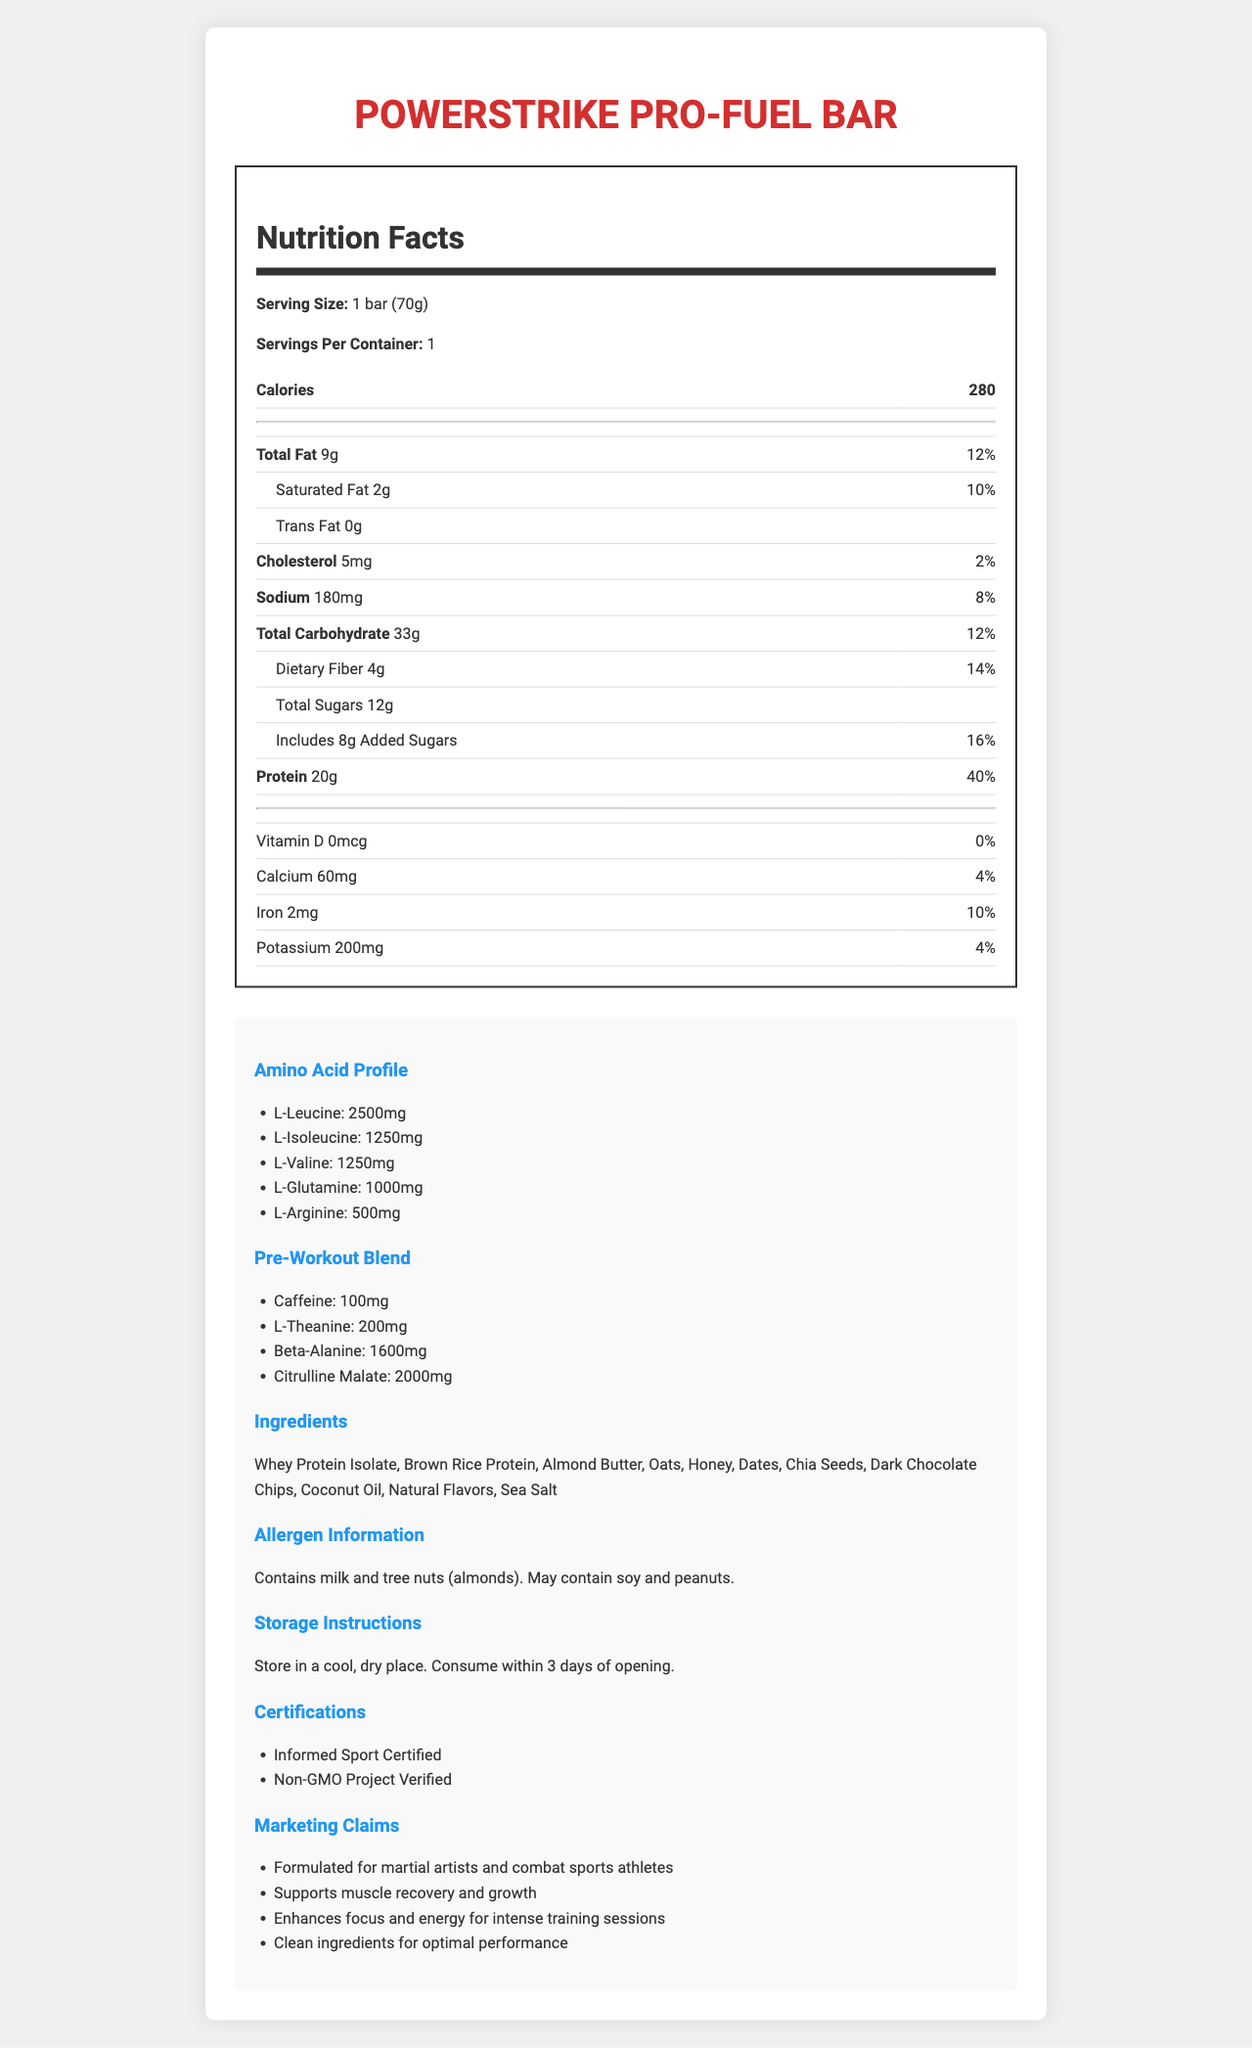What is the serving size of the PowerStrike Pro-Fuel Bar? The serving size is explicitly stated as "1 bar (70g)" in the Nutrition Facts section.
Answer: 1 bar (70g) How many calories are in one serving of the PowerStrike Pro-Fuel Bar? The document lists the calorie content as 280 in the Nutrition Facts section.
Answer: 280 calories List three main ingredients in the PowerStrike Pro-Fuel Bar. These ingredients are mentioned at the beginning of the ingredients list.
Answer: Whey Protein Isolate, Brown Rice Protein, Almond Butter What is the amount of protein in one bar of PowerStrike Pro-Fuel Bar? The document states that the protein content is 20g per serving in the Nutrition Facts section.
Answer: 20g What certifications does the PowerStrike Pro-Fuel Bar have? These certifications are listed under Certifications in the extra info section.
Answer: Informed Sport Certified, Non-GMO Project Verified What is the total fat content of the PowerStrike Pro-Fuel Bar? The total fat content is listed as 9g in the Nutrition Facts section.
Answer: 9g A. Reduces stress
B. Supports muscle recovery and growth
C. Enhances focus and energy for intense training sessions
D. Clean ingredients for optimal performance The document lists these claims under Marketing Claims in the extra info section.
Answer: B, C, D A. Gluten
B. Milk
C. Tree Nuts (almonds)
D. Soy According to the allergen information section, the bar contains milk and tree nuts (almonds) and may contain soy.
Answer: B, C True or False: The PowerStrike Pro-Fuel Bar is suitable for vegetarians. The main ingredient is Whey Protein Isolate which is derived from milk, making it unsuitable for vegetarians.
Answer: False Summarize the information provided in the document about the PowerStrike Pro-Fuel Bar. The summary encapsulates the main points such as the target audience, nutritional details, certifications, allergens, and storage instructions.
Answer: The PowerStrike Pro-Fuel Bar is a nutrition bar formulated specifically for martial artists and combat sports athletes. Each 70g bar contains 280 calories, with 20g of protein and 33g of carbohydrates. It also contains a blend of pre-workout ingredients, including caffeine and beta-alanine, and an amino acid profile. The bar is Informed Sport Certified and Non-GMO Project Verified. It contains allergens like milk and tree nuts and provides instructions for storage. How long can you keep an opened PowerStrike Pro-Fuel Bar? The storage instructions mention that the bar should be consumed within 3 days of opening.
Answer: 3 days A. L-Glutamine
B. L-Arginine
C. L-Leucine
D. L-Valine L-Leucine has the highest content at 2500mg, compared to others listed in the Amino Acid Profile section.
Answer: C What is the daily value percentage of saturated fat in one serving of the PowerStrike Pro-Fuel Bar? The Nutrition Facts section states that the daily value percentage of saturated fat is 10%.
Answer: 10% What is the exact level of Vitamin D in the PowerStrike Pro-Fuel Bar? The Vitamin D content is 0 mcg as listed in the Nutrition Facts section.
Answer: 0 mcg Does the PowerStrike Pro-Fuel Bar contain any trans fat? The Nutrition Facts section indicates that the trans fat content is 0g.
Answer: No What is the reason behind this product being suitable specifically for martial artists and combat sports athletes? The document states it is formulated for martial artists and combat sports athletes but doesn't provide enough specific details to explain why.
Answer: Not enough information 